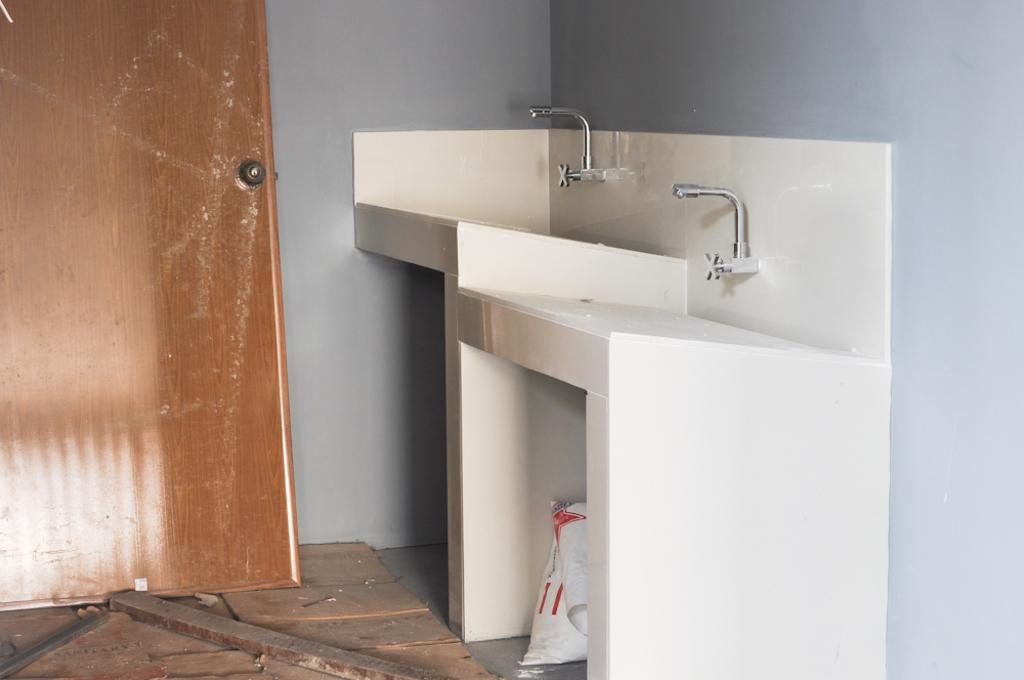What type of structure can be seen in the image? There is a door in the image. What can be used to control the flow of water in the image? There is a tap in the image. What type of architectural element is present in the image? There is a wall in the image. What direction is the wind blowing in the image? There is no wind present in the image. What type of flowers can be seen growing on the wall in the image? There are no flowers present in the image; only a door, a tap, and a wall are visible. 